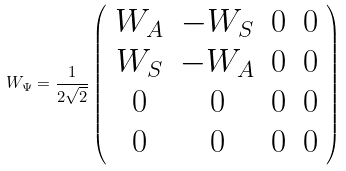Convert formula to latex. <formula><loc_0><loc_0><loc_500><loc_500>W _ { \Psi } = \frac { 1 } { 2 \sqrt { 2 } } \left ( \begin{array} { c c c c } W _ { A } & - W _ { S } & 0 & 0 \\ W _ { S } & - W _ { A } & 0 & 0 \\ 0 & 0 & 0 & 0 \\ 0 & 0 & 0 & 0 \\ \end{array} \right )</formula> 